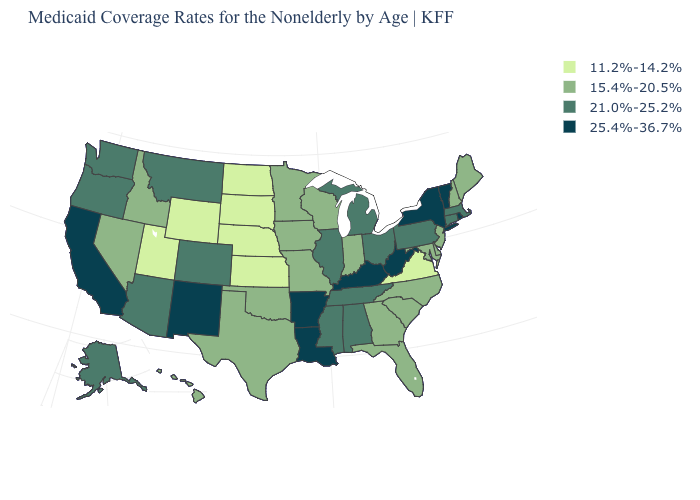What is the value of New York?
Give a very brief answer. 25.4%-36.7%. Is the legend a continuous bar?
Be succinct. No. Name the states that have a value in the range 15.4%-20.5%?
Quick response, please. Delaware, Florida, Georgia, Hawaii, Idaho, Indiana, Iowa, Maine, Maryland, Minnesota, Missouri, Nevada, New Hampshire, New Jersey, North Carolina, Oklahoma, South Carolina, Texas, Wisconsin. Name the states that have a value in the range 25.4%-36.7%?
Write a very short answer. Arkansas, California, Kentucky, Louisiana, New Mexico, New York, Rhode Island, Vermont, West Virginia. What is the lowest value in the USA?
Keep it brief. 11.2%-14.2%. Name the states that have a value in the range 11.2%-14.2%?
Quick response, please. Kansas, Nebraska, North Dakota, South Dakota, Utah, Virginia, Wyoming. Does the map have missing data?
Concise answer only. No. Does the map have missing data?
Keep it brief. No. Among the states that border Montana , which have the lowest value?
Answer briefly. North Dakota, South Dakota, Wyoming. Name the states that have a value in the range 21.0%-25.2%?
Short answer required. Alabama, Alaska, Arizona, Colorado, Connecticut, Illinois, Massachusetts, Michigan, Mississippi, Montana, Ohio, Oregon, Pennsylvania, Tennessee, Washington. Name the states that have a value in the range 11.2%-14.2%?
Quick response, please. Kansas, Nebraska, North Dakota, South Dakota, Utah, Virginia, Wyoming. What is the value of Arkansas?
Be succinct. 25.4%-36.7%. What is the value of New Mexico?
Answer briefly. 25.4%-36.7%. 